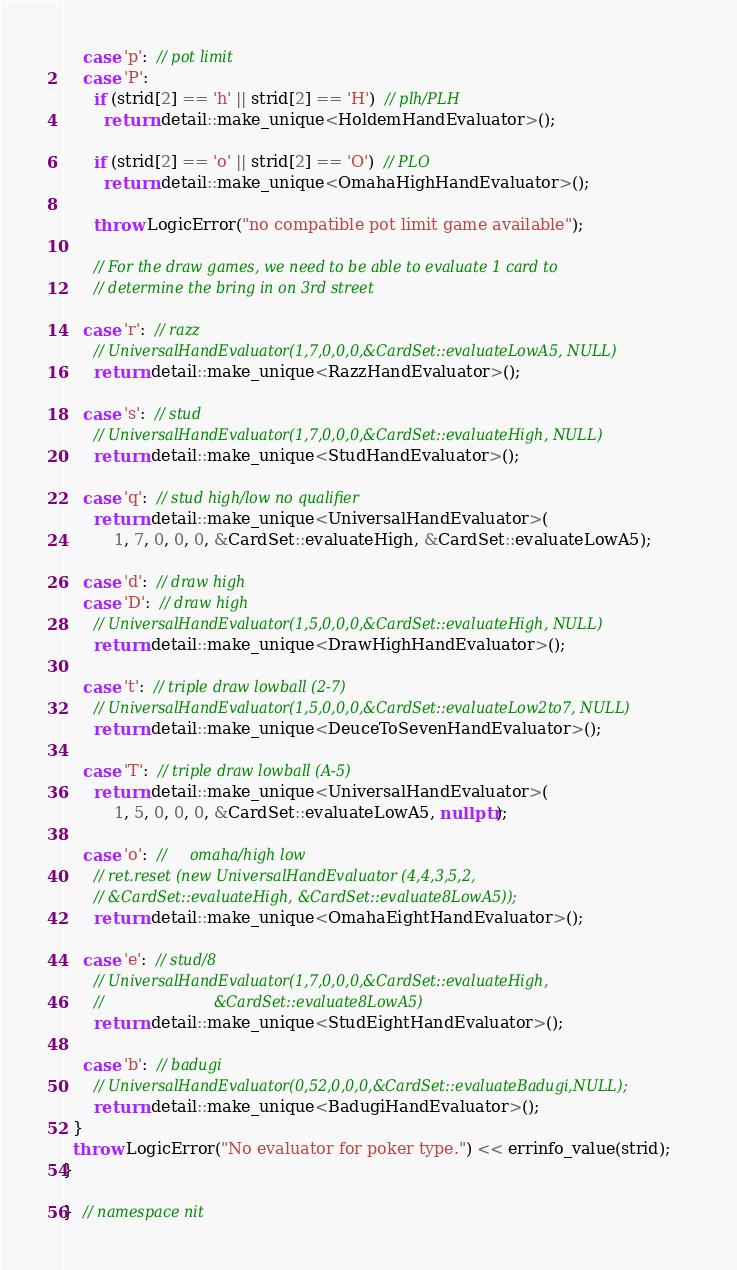<code> <loc_0><loc_0><loc_500><loc_500><_C++_>
    case 'p':  // pot limit
    case 'P':
      if (strid[2] == 'h' || strid[2] == 'H')  // plh/PLH
        return detail::make_unique<HoldemHandEvaluator>();

      if (strid[2] == 'o' || strid[2] == 'O')  // PLO
        return detail::make_unique<OmahaHighHandEvaluator>();

      throw LogicError("no compatible pot limit game available");

      // For the draw games, we need to be able to evaluate 1 card to
      // determine the bring in on 3rd street

    case 'r':  // razz
      // UniversalHandEvaluator(1,7,0,0,0,&CardSet::evaluateLowA5, NULL)
      return detail::make_unique<RazzHandEvaluator>();

    case 's':  // stud
      // UniversalHandEvaluator(1,7,0,0,0,&CardSet::evaluateHigh, NULL)
      return detail::make_unique<StudHandEvaluator>();

    case 'q':  // stud high/low no qualifier
      return detail::make_unique<UniversalHandEvaluator>(
          1, 7, 0, 0, 0, &CardSet::evaluateHigh, &CardSet::evaluateLowA5);

    case 'd':  // draw high
    case 'D':  // draw high
      // UniversalHandEvaluator(1,5,0,0,0,&CardSet::evaluateHigh, NULL)
      return detail::make_unique<DrawHighHandEvaluator>();

    case 't':  // triple draw lowball (2-7)
      // UniversalHandEvaluator(1,5,0,0,0,&CardSet::evaluateLow2to7, NULL)
      return detail::make_unique<DeuceToSevenHandEvaluator>();

    case 'T':  // triple draw lowball (A-5)
      return detail::make_unique<UniversalHandEvaluator>(
          1, 5, 0, 0, 0, &CardSet::evaluateLowA5, nullptr);

    case 'o':  //     omaha/high low
      // ret.reset (new UniversalHandEvaluator (4,4,3,5,2,
      // &CardSet::evaluateHigh, &CardSet::evaluate8LowA5));
      return detail::make_unique<OmahaEightHandEvaluator>();

    case 'e':  // stud/8
      // UniversalHandEvaluator(1,7,0,0,0,&CardSet::evaluateHigh,
      //                        &CardSet::evaluate8LowA5)
      return detail::make_unique<StudEightHandEvaluator>();

    case 'b':  // badugi
      // UniversalHandEvaluator(0,52,0,0,0,&CardSet::evaluateBadugi,NULL);
      return detail::make_unique<BadugiHandEvaluator>();
  }
  throw LogicError("No evaluator for poker type.") << errinfo_value(strid);
}

}  // namespace nit
</code> 